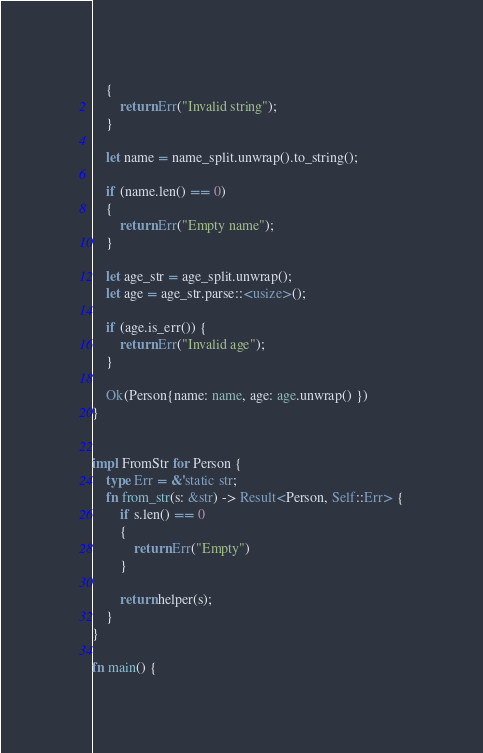Convert code to text. <code><loc_0><loc_0><loc_500><loc_500><_Rust_>    {
        return Err("Invalid string");   
    }

    let name = name_split.unwrap().to_string();

    if (name.len() == 0)
    {
        return Err("Empty name");
    }

    let age_str = age_split.unwrap();
    let age = age_str.parse::<usize>();

    if (age.is_err()) {
        return Err("Invalid age");
    }

    Ok(Person{name: name, age: age.unwrap() })
}


impl FromStr for Person {
    type Err = &'static str;
    fn from_str(s: &str) -> Result<Person, Self::Err> {
        if s.len() == 0
        {
            return Err("Empty")
        }

        return helper(s);
    }
}

fn main() {</code> 